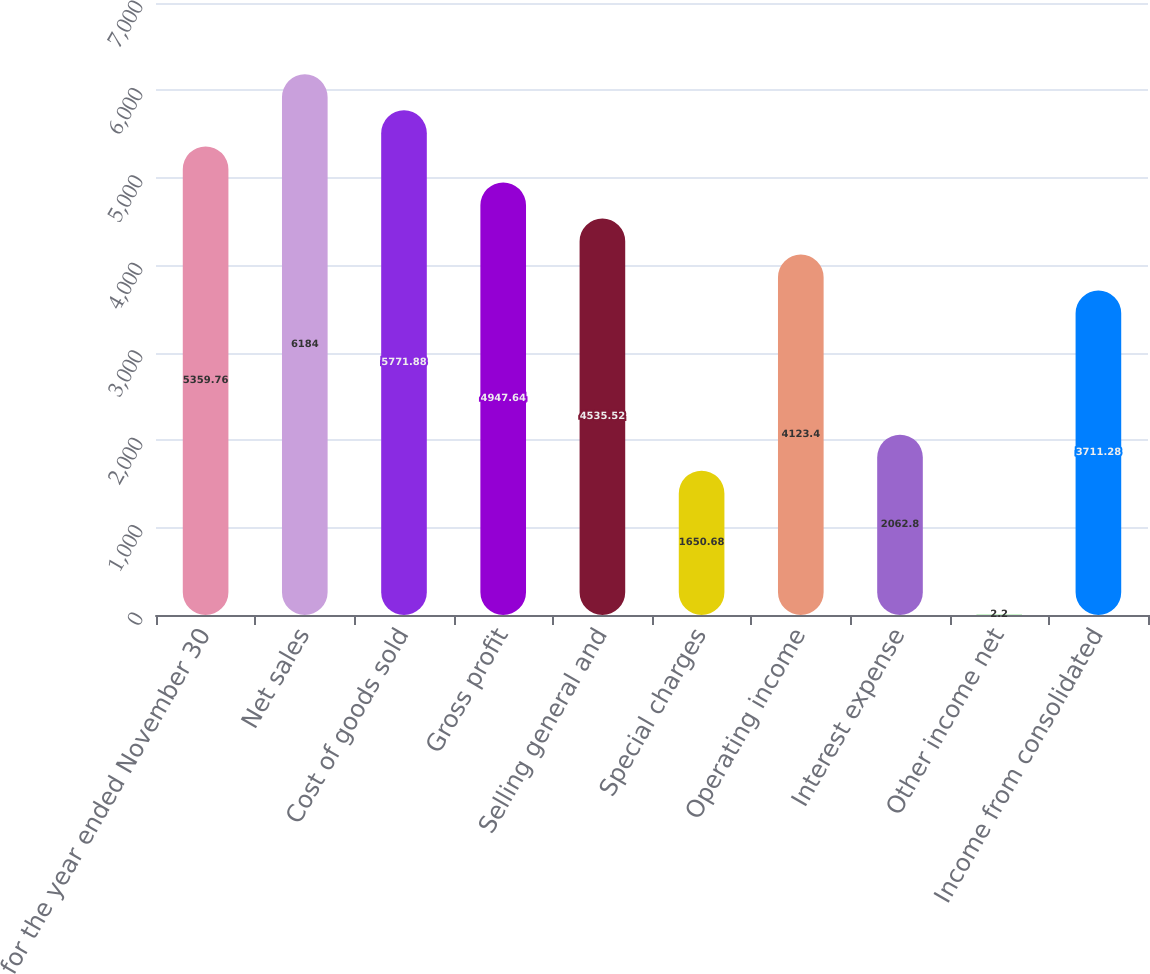Convert chart to OTSL. <chart><loc_0><loc_0><loc_500><loc_500><bar_chart><fcel>for the year ended November 30<fcel>Net sales<fcel>Cost of goods sold<fcel>Gross profit<fcel>Selling general and<fcel>Special charges<fcel>Operating income<fcel>Interest expense<fcel>Other income net<fcel>Income from consolidated<nl><fcel>5359.76<fcel>6184<fcel>5771.88<fcel>4947.64<fcel>4535.52<fcel>1650.68<fcel>4123.4<fcel>2062.8<fcel>2.2<fcel>3711.28<nl></chart> 